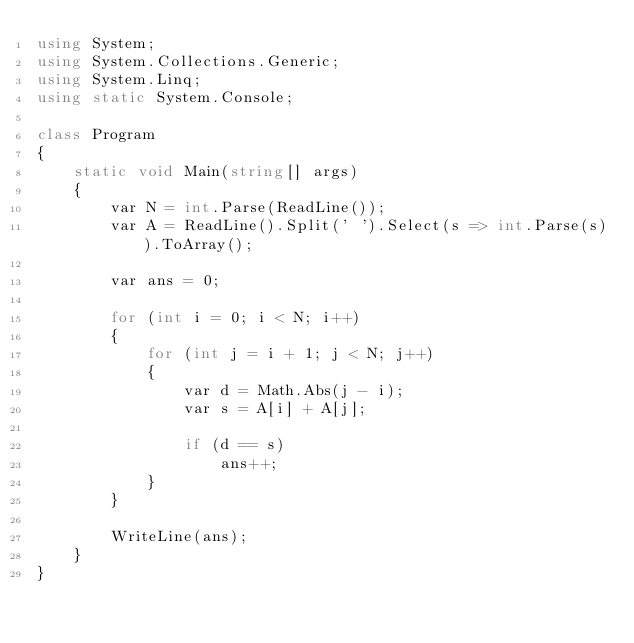Convert code to text. <code><loc_0><loc_0><loc_500><loc_500><_C#_>using System;
using System.Collections.Generic;
using System.Linq;
using static System.Console;

class Program
{
    static void Main(string[] args)
    {
        var N = int.Parse(ReadLine());
        var A = ReadLine().Split(' ').Select(s => int.Parse(s)).ToArray();

        var ans = 0;

        for (int i = 0; i < N; i++)
        {
            for (int j = i + 1; j < N; j++)
            {
                var d = Math.Abs(j - i);
                var s = A[i] + A[j];

                if (d == s)
                    ans++;
            }
        }

        WriteLine(ans);
    }
}
</code> 